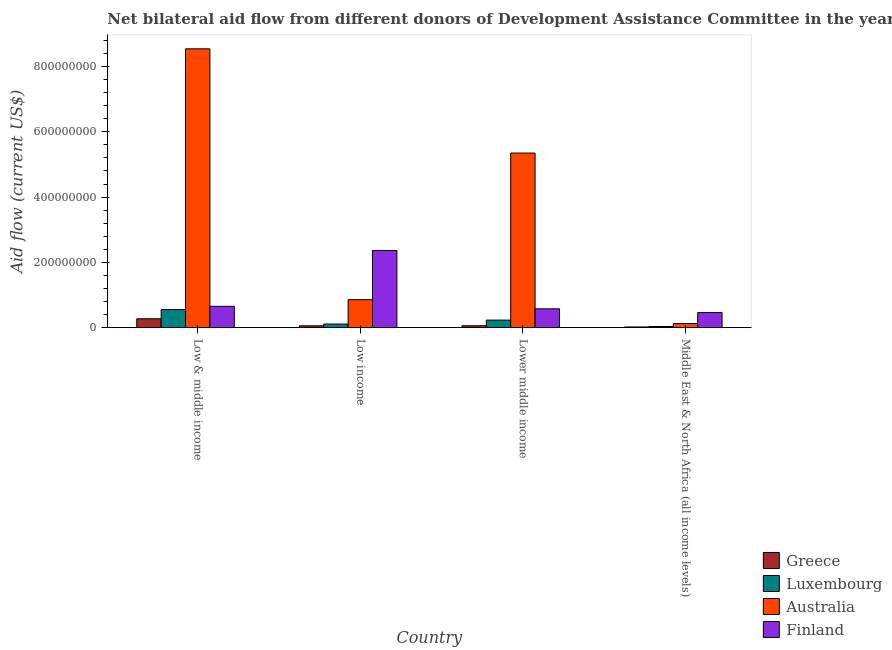How many groups of bars are there?
Offer a terse response. 4. What is the label of the 2nd group of bars from the left?
Your response must be concise. Low income. What is the amount of aid given by luxembourg in Lower middle income?
Give a very brief answer. 2.32e+07. Across all countries, what is the maximum amount of aid given by luxembourg?
Offer a very short reply. 5.56e+07. Across all countries, what is the minimum amount of aid given by finland?
Your answer should be compact. 4.63e+07. In which country was the amount of aid given by greece minimum?
Your response must be concise. Middle East & North Africa (all income levels). What is the total amount of aid given by greece in the graph?
Ensure brevity in your answer.  4.11e+07. What is the difference between the amount of aid given by greece in Low income and that in Lower middle income?
Your answer should be compact. -2.10e+05. What is the difference between the amount of aid given by australia in Low & middle income and the amount of aid given by luxembourg in Middle East & North Africa (all income levels)?
Make the answer very short. 8.51e+08. What is the average amount of aid given by australia per country?
Your answer should be compact. 3.72e+08. What is the difference between the amount of aid given by luxembourg and amount of aid given by australia in Low & middle income?
Offer a very short reply. -7.98e+08. What is the ratio of the amount of aid given by australia in Low income to that in Lower middle income?
Keep it short and to the point. 0.16. Is the difference between the amount of aid given by finland in Low income and Middle East & North Africa (all income levels) greater than the difference between the amount of aid given by greece in Low income and Middle East & North Africa (all income levels)?
Your answer should be very brief. Yes. What is the difference between the highest and the second highest amount of aid given by finland?
Ensure brevity in your answer.  1.71e+08. What is the difference between the highest and the lowest amount of aid given by finland?
Provide a succinct answer. 1.90e+08. Are all the bars in the graph horizontal?
Your answer should be very brief. No. Does the graph contain grids?
Your response must be concise. No. Where does the legend appear in the graph?
Provide a succinct answer. Bottom right. How are the legend labels stacked?
Give a very brief answer. Vertical. What is the title of the graph?
Your answer should be compact. Net bilateral aid flow from different donors of Development Assistance Committee in the year 1996. Does "Efficiency of custom clearance process" appear as one of the legend labels in the graph?
Provide a short and direct response. No. What is the Aid flow (current US$) in Greece in Low & middle income?
Provide a succinct answer. 2.73e+07. What is the Aid flow (current US$) in Luxembourg in Low & middle income?
Offer a very short reply. 5.56e+07. What is the Aid flow (current US$) of Australia in Low & middle income?
Keep it short and to the point. 8.54e+08. What is the Aid flow (current US$) in Finland in Low & middle income?
Keep it short and to the point. 6.54e+07. What is the Aid flow (current US$) in Greece in Low income?
Your answer should be compact. 5.72e+06. What is the Aid flow (current US$) of Luxembourg in Low income?
Offer a very short reply. 1.12e+07. What is the Aid flow (current US$) of Australia in Low income?
Make the answer very short. 8.58e+07. What is the Aid flow (current US$) in Finland in Low income?
Provide a succinct answer. 2.36e+08. What is the Aid flow (current US$) of Greece in Lower middle income?
Offer a very short reply. 5.93e+06. What is the Aid flow (current US$) of Luxembourg in Lower middle income?
Provide a short and direct response. 2.32e+07. What is the Aid flow (current US$) of Australia in Lower middle income?
Make the answer very short. 5.35e+08. What is the Aid flow (current US$) in Finland in Lower middle income?
Your response must be concise. 5.77e+07. What is the Aid flow (current US$) in Greece in Middle East & North Africa (all income levels)?
Ensure brevity in your answer.  2.15e+06. What is the Aid flow (current US$) in Luxembourg in Middle East & North Africa (all income levels)?
Provide a succinct answer. 3.48e+06. What is the Aid flow (current US$) in Australia in Middle East & North Africa (all income levels)?
Your answer should be very brief. 1.26e+07. What is the Aid flow (current US$) in Finland in Middle East & North Africa (all income levels)?
Provide a short and direct response. 4.63e+07. Across all countries, what is the maximum Aid flow (current US$) in Greece?
Your answer should be compact. 2.73e+07. Across all countries, what is the maximum Aid flow (current US$) of Luxembourg?
Your response must be concise. 5.56e+07. Across all countries, what is the maximum Aid flow (current US$) of Australia?
Provide a short and direct response. 8.54e+08. Across all countries, what is the maximum Aid flow (current US$) in Finland?
Provide a succinct answer. 2.36e+08. Across all countries, what is the minimum Aid flow (current US$) of Greece?
Your answer should be compact. 2.15e+06. Across all countries, what is the minimum Aid flow (current US$) of Luxembourg?
Offer a very short reply. 3.48e+06. Across all countries, what is the minimum Aid flow (current US$) in Australia?
Give a very brief answer. 1.26e+07. Across all countries, what is the minimum Aid flow (current US$) of Finland?
Your response must be concise. 4.63e+07. What is the total Aid flow (current US$) of Greece in the graph?
Offer a very short reply. 4.11e+07. What is the total Aid flow (current US$) of Luxembourg in the graph?
Your answer should be compact. 9.35e+07. What is the total Aid flow (current US$) of Australia in the graph?
Ensure brevity in your answer.  1.49e+09. What is the total Aid flow (current US$) in Finland in the graph?
Offer a terse response. 4.06e+08. What is the difference between the Aid flow (current US$) in Greece in Low & middle income and that in Low income?
Ensure brevity in your answer.  2.16e+07. What is the difference between the Aid flow (current US$) in Luxembourg in Low & middle income and that in Low income?
Provide a short and direct response. 4.45e+07. What is the difference between the Aid flow (current US$) of Australia in Low & middle income and that in Low income?
Provide a short and direct response. 7.68e+08. What is the difference between the Aid flow (current US$) in Finland in Low & middle income and that in Low income?
Your answer should be very brief. -1.71e+08. What is the difference between the Aid flow (current US$) of Greece in Low & middle income and that in Lower middle income?
Provide a succinct answer. 2.14e+07. What is the difference between the Aid flow (current US$) of Luxembourg in Low & middle income and that in Lower middle income?
Your response must be concise. 3.24e+07. What is the difference between the Aid flow (current US$) of Australia in Low & middle income and that in Lower middle income?
Provide a succinct answer. 3.19e+08. What is the difference between the Aid flow (current US$) of Finland in Low & middle income and that in Lower middle income?
Your answer should be compact. 7.66e+06. What is the difference between the Aid flow (current US$) of Greece in Low & middle income and that in Middle East & North Africa (all income levels)?
Give a very brief answer. 2.52e+07. What is the difference between the Aid flow (current US$) in Luxembourg in Low & middle income and that in Middle East & North Africa (all income levels)?
Provide a short and direct response. 5.22e+07. What is the difference between the Aid flow (current US$) in Australia in Low & middle income and that in Middle East & North Africa (all income levels)?
Ensure brevity in your answer.  8.41e+08. What is the difference between the Aid flow (current US$) of Finland in Low & middle income and that in Middle East & North Africa (all income levels)?
Your answer should be compact. 1.91e+07. What is the difference between the Aid flow (current US$) in Luxembourg in Low income and that in Lower middle income?
Provide a succinct answer. -1.20e+07. What is the difference between the Aid flow (current US$) of Australia in Low income and that in Lower middle income?
Ensure brevity in your answer.  -4.49e+08. What is the difference between the Aid flow (current US$) of Finland in Low income and that in Lower middle income?
Your answer should be compact. 1.79e+08. What is the difference between the Aid flow (current US$) of Greece in Low income and that in Middle East & North Africa (all income levels)?
Provide a short and direct response. 3.57e+06. What is the difference between the Aid flow (current US$) of Luxembourg in Low income and that in Middle East & North Africa (all income levels)?
Provide a short and direct response. 7.69e+06. What is the difference between the Aid flow (current US$) in Australia in Low income and that in Middle East & North Africa (all income levels)?
Ensure brevity in your answer.  7.32e+07. What is the difference between the Aid flow (current US$) of Finland in Low income and that in Middle East & North Africa (all income levels)?
Ensure brevity in your answer.  1.90e+08. What is the difference between the Aid flow (current US$) in Greece in Lower middle income and that in Middle East & North Africa (all income levels)?
Offer a terse response. 3.78e+06. What is the difference between the Aid flow (current US$) in Luxembourg in Lower middle income and that in Middle East & North Africa (all income levels)?
Make the answer very short. 1.97e+07. What is the difference between the Aid flow (current US$) of Australia in Lower middle income and that in Middle East & North Africa (all income levels)?
Your answer should be very brief. 5.22e+08. What is the difference between the Aid flow (current US$) in Finland in Lower middle income and that in Middle East & North Africa (all income levels)?
Make the answer very short. 1.14e+07. What is the difference between the Aid flow (current US$) of Greece in Low & middle income and the Aid flow (current US$) of Luxembourg in Low income?
Provide a short and direct response. 1.61e+07. What is the difference between the Aid flow (current US$) in Greece in Low & middle income and the Aid flow (current US$) in Australia in Low income?
Offer a very short reply. -5.85e+07. What is the difference between the Aid flow (current US$) in Greece in Low & middle income and the Aid flow (current US$) in Finland in Low income?
Give a very brief answer. -2.09e+08. What is the difference between the Aid flow (current US$) in Luxembourg in Low & middle income and the Aid flow (current US$) in Australia in Low income?
Ensure brevity in your answer.  -3.02e+07. What is the difference between the Aid flow (current US$) in Luxembourg in Low & middle income and the Aid flow (current US$) in Finland in Low income?
Provide a succinct answer. -1.81e+08. What is the difference between the Aid flow (current US$) in Australia in Low & middle income and the Aid flow (current US$) in Finland in Low income?
Ensure brevity in your answer.  6.18e+08. What is the difference between the Aid flow (current US$) in Greece in Low & middle income and the Aid flow (current US$) in Luxembourg in Lower middle income?
Make the answer very short. 4.13e+06. What is the difference between the Aid flow (current US$) of Greece in Low & middle income and the Aid flow (current US$) of Australia in Lower middle income?
Your answer should be compact. -5.08e+08. What is the difference between the Aid flow (current US$) of Greece in Low & middle income and the Aid flow (current US$) of Finland in Lower middle income?
Your answer should be compact. -3.04e+07. What is the difference between the Aid flow (current US$) in Luxembourg in Low & middle income and the Aid flow (current US$) in Australia in Lower middle income?
Offer a very short reply. -4.79e+08. What is the difference between the Aid flow (current US$) in Luxembourg in Low & middle income and the Aid flow (current US$) in Finland in Lower middle income?
Offer a terse response. -2.08e+06. What is the difference between the Aid flow (current US$) of Australia in Low & middle income and the Aid flow (current US$) of Finland in Lower middle income?
Provide a short and direct response. 7.96e+08. What is the difference between the Aid flow (current US$) in Greece in Low & middle income and the Aid flow (current US$) in Luxembourg in Middle East & North Africa (all income levels)?
Provide a succinct answer. 2.38e+07. What is the difference between the Aid flow (current US$) of Greece in Low & middle income and the Aid flow (current US$) of Australia in Middle East & North Africa (all income levels)?
Keep it short and to the point. 1.47e+07. What is the difference between the Aid flow (current US$) of Greece in Low & middle income and the Aid flow (current US$) of Finland in Middle East & North Africa (all income levels)?
Your answer should be compact. -1.90e+07. What is the difference between the Aid flow (current US$) of Luxembourg in Low & middle income and the Aid flow (current US$) of Australia in Middle East & North Africa (all income levels)?
Offer a very short reply. 4.30e+07. What is the difference between the Aid flow (current US$) in Luxembourg in Low & middle income and the Aid flow (current US$) in Finland in Middle East & North Africa (all income levels)?
Keep it short and to the point. 9.36e+06. What is the difference between the Aid flow (current US$) in Australia in Low & middle income and the Aid flow (current US$) in Finland in Middle East & North Africa (all income levels)?
Your response must be concise. 8.08e+08. What is the difference between the Aid flow (current US$) in Greece in Low income and the Aid flow (current US$) in Luxembourg in Lower middle income?
Make the answer very short. -1.75e+07. What is the difference between the Aid flow (current US$) in Greece in Low income and the Aid flow (current US$) in Australia in Lower middle income?
Keep it short and to the point. -5.29e+08. What is the difference between the Aid flow (current US$) in Greece in Low income and the Aid flow (current US$) in Finland in Lower middle income?
Provide a short and direct response. -5.20e+07. What is the difference between the Aid flow (current US$) of Luxembourg in Low income and the Aid flow (current US$) of Australia in Lower middle income?
Your answer should be compact. -5.24e+08. What is the difference between the Aid flow (current US$) of Luxembourg in Low income and the Aid flow (current US$) of Finland in Lower middle income?
Keep it short and to the point. -4.65e+07. What is the difference between the Aid flow (current US$) in Australia in Low income and the Aid flow (current US$) in Finland in Lower middle income?
Your response must be concise. 2.81e+07. What is the difference between the Aid flow (current US$) in Greece in Low income and the Aid flow (current US$) in Luxembourg in Middle East & North Africa (all income levels)?
Offer a terse response. 2.24e+06. What is the difference between the Aid flow (current US$) of Greece in Low income and the Aid flow (current US$) of Australia in Middle East & North Africa (all income levels)?
Your answer should be compact. -6.92e+06. What is the difference between the Aid flow (current US$) in Greece in Low income and the Aid flow (current US$) in Finland in Middle East & North Africa (all income levels)?
Ensure brevity in your answer.  -4.06e+07. What is the difference between the Aid flow (current US$) in Luxembourg in Low income and the Aid flow (current US$) in Australia in Middle East & North Africa (all income levels)?
Your response must be concise. -1.47e+06. What is the difference between the Aid flow (current US$) in Luxembourg in Low income and the Aid flow (current US$) in Finland in Middle East & North Africa (all income levels)?
Make the answer very short. -3.51e+07. What is the difference between the Aid flow (current US$) of Australia in Low income and the Aid flow (current US$) of Finland in Middle East & North Africa (all income levels)?
Provide a short and direct response. 3.96e+07. What is the difference between the Aid flow (current US$) in Greece in Lower middle income and the Aid flow (current US$) in Luxembourg in Middle East & North Africa (all income levels)?
Provide a short and direct response. 2.45e+06. What is the difference between the Aid flow (current US$) in Greece in Lower middle income and the Aid flow (current US$) in Australia in Middle East & North Africa (all income levels)?
Your answer should be very brief. -6.71e+06. What is the difference between the Aid flow (current US$) of Greece in Lower middle income and the Aid flow (current US$) of Finland in Middle East & North Africa (all income levels)?
Give a very brief answer. -4.03e+07. What is the difference between the Aid flow (current US$) of Luxembourg in Lower middle income and the Aid flow (current US$) of Australia in Middle East & North Africa (all income levels)?
Offer a very short reply. 1.05e+07. What is the difference between the Aid flow (current US$) of Luxembourg in Lower middle income and the Aid flow (current US$) of Finland in Middle East & North Africa (all income levels)?
Ensure brevity in your answer.  -2.31e+07. What is the difference between the Aid flow (current US$) in Australia in Lower middle income and the Aid flow (current US$) in Finland in Middle East & North Africa (all income levels)?
Offer a very short reply. 4.89e+08. What is the average Aid flow (current US$) of Greece per country?
Give a very brief answer. 1.03e+07. What is the average Aid flow (current US$) of Luxembourg per country?
Provide a short and direct response. 2.34e+07. What is the average Aid flow (current US$) of Australia per country?
Keep it short and to the point. 3.72e+08. What is the average Aid flow (current US$) in Finland per country?
Offer a terse response. 1.01e+08. What is the difference between the Aid flow (current US$) of Greece and Aid flow (current US$) of Luxembourg in Low & middle income?
Provide a short and direct response. -2.83e+07. What is the difference between the Aid flow (current US$) in Greece and Aid flow (current US$) in Australia in Low & middle income?
Your answer should be very brief. -8.27e+08. What is the difference between the Aid flow (current US$) in Greece and Aid flow (current US$) in Finland in Low & middle income?
Your response must be concise. -3.81e+07. What is the difference between the Aid flow (current US$) of Luxembourg and Aid flow (current US$) of Australia in Low & middle income?
Your response must be concise. -7.98e+08. What is the difference between the Aid flow (current US$) in Luxembourg and Aid flow (current US$) in Finland in Low & middle income?
Offer a very short reply. -9.74e+06. What is the difference between the Aid flow (current US$) in Australia and Aid flow (current US$) in Finland in Low & middle income?
Ensure brevity in your answer.  7.89e+08. What is the difference between the Aid flow (current US$) in Greece and Aid flow (current US$) in Luxembourg in Low income?
Offer a terse response. -5.45e+06. What is the difference between the Aid flow (current US$) of Greece and Aid flow (current US$) of Australia in Low income?
Provide a succinct answer. -8.01e+07. What is the difference between the Aid flow (current US$) of Greece and Aid flow (current US$) of Finland in Low income?
Your response must be concise. -2.31e+08. What is the difference between the Aid flow (current US$) of Luxembourg and Aid flow (current US$) of Australia in Low income?
Provide a succinct answer. -7.47e+07. What is the difference between the Aid flow (current US$) in Luxembourg and Aid flow (current US$) in Finland in Low income?
Your answer should be compact. -2.25e+08. What is the difference between the Aid flow (current US$) of Australia and Aid flow (current US$) of Finland in Low income?
Ensure brevity in your answer.  -1.51e+08. What is the difference between the Aid flow (current US$) in Greece and Aid flow (current US$) in Luxembourg in Lower middle income?
Your answer should be compact. -1.72e+07. What is the difference between the Aid flow (current US$) in Greece and Aid flow (current US$) in Australia in Lower middle income?
Your answer should be very brief. -5.29e+08. What is the difference between the Aid flow (current US$) in Greece and Aid flow (current US$) in Finland in Lower middle income?
Give a very brief answer. -5.18e+07. What is the difference between the Aid flow (current US$) of Luxembourg and Aid flow (current US$) of Australia in Lower middle income?
Provide a succinct answer. -5.12e+08. What is the difference between the Aid flow (current US$) of Luxembourg and Aid flow (current US$) of Finland in Lower middle income?
Ensure brevity in your answer.  -3.45e+07. What is the difference between the Aid flow (current US$) of Australia and Aid flow (current US$) of Finland in Lower middle income?
Offer a very short reply. 4.77e+08. What is the difference between the Aid flow (current US$) in Greece and Aid flow (current US$) in Luxembourg in Middle East & North Africa (all income levels)?
Make the answer very short. -1.33e+06. What is the difference between the Aid flow (current US$) in Greece and Aid flow (current US$) in Australia in Middle East & North Africa (all income levels)?
Provide a short and direct response. -1.05e+07. What is the difference between the Aid flow (current US$) of Greece and Aid flow (current US$) of Finland in Middle East & North Africa (all income levels)?
Give a very brief answer. -4.41e+07. What is the difference between the Aid flow (current US$) of Luxembourg and Aid flow (current US$) of Australia in Middle East & North Africa (all income levels)?
Your answer should be compact. -9.16e+06. What is the difference between the Aid flow (current US$) of Luxembourg and Aid flow (current US$) of Finland in Middle East & North Africa (all income levels)?
Provide a succinct answer. -4.28e+07. What is the difference between the Aid flow (current US$) of Australia and Aid flow (current US$) of Finland in Middle East & North Africa (all income levels)?
Your answer should be compact. -3.36e+07. What is the ratio of the Aid flow (current US$) of Greece in Low & middle income to that in Low income?
Give a very brief answer. 4.77. What is the ratio of the Aid flow (current US$) in Luxembourg in Low & middle income to that in Low income?
Keep it short and to the point. 4.98. What is the ratio of the Aid flow (current US$) in Australia in Low & middle income to that in Low income?
Your answer should be very brief. 9.95. What is the ratio of the Aid flow (current US$) in Finland in Low & middle income to that in Low income?
Your response must be concise. 0.28. What is the ratio of the Aid flow (current US$) in Greece in Low & middle income to that in Lower middle income?
Make the answer very short. 4.61. What is the ratio of the Aid flow (current US$) of Luxembourg in Low & middle income to that in Lower middle income?
Ensure brevity in your answer.  2.4. What is the ratio of the Aid flow (current US$) in Australia in Low & middle income to that in Lower middle income?
Make the answer very short. 1.6. What is the ratio of the Aid flow (current US$) of Finland in Low & middle income to that in Lower middle income?
Make the answer very short. 1.13. What is the ratio of the Aid flow (current US$) of Greece in Low & middle income to that in Middle East & North Africa (all income levels)?
Keep it short and to the point. 12.7. What is the ratio of the Aid flow (current US$) in Luxembourg in Low & middle income to that in Middle East & North Africa (all income levels)?
Your response must be concise. 15.99. What is the ratio of the Aid flow (current US$) of Australia in Low & middle income to that in Middle East & North Africa (all income levels)?
Provide a short and direct response. 67.57. What is the ratio of the Aid flow (current US$) in Finland in Low & middle income to that in Middle East & North Africa (all income levels)?
Your response must be concise. 1.41. What is the ratio of the Aid flow (current US$) in Greece in Low income to that in Lower middle income?
Your answer should be compact. 0.96. What is the ratio of the Aid flow (current US$) in Luxembourg in Low income to that in Lower middle income?
Ensure brevity in your answer.  0.48. What is the ratio of the Aid flow (current US$) in Australia in Low income to that in Lower middle income?
Your answer should be very brief. 0.16. What is the ratio of the Aid flow (current US$) of Finland in Low income to that in Lower middle income?
Your answer should be compact. 4.1. What is the ratio of the Aid flow (current US$) in Greece in Low income to that in Middle East & North Africa (all income levels)?
Offer a very short reply. 2.66. What is the ratio of the Aid flow (current US$) in Luxembourg in Low income to that in Middle East & North Africa (all income levels)?
Offer a terse response. 3.21. What is the ratio of the Aid flow (current US$) in Australia in Low income to that in Middle East & North Africa (all income levels)?
Keep it short and to the point. 6.79. What is the ratio of the Aid flow (current US$) of Finland in Low income to that in Middle East & North Africa (all income levels)?
Offer a terse response. 5.11. What is the ratio of the Aid flow (current US$) of Greece in Lower middle income to that in Middle East & North Africa (all income levels)?
Your response must be concise. 2.76. What is the ratio of the Aid flow (current US$) in Luxembourg in Lower middle income to that in Middle East & North Africa (all income levels)?
Ensure brevity in your answer.  6.66. What is the ratio of the Aid flow (current US$) in Australia in Lower middle income to that in Middle East & North Africa (all income levels)?
Your answer should be compact. 42.31. What is the ratio of the Aid flow (current US$) in Finland in Lower middle income to that in Middle East & North Africa (all income levels)?
Make the answer very short. 1.25. What is the difference between the highest and the second highest Aid flow (current US$) in Greece?
Offer a terse response. 2.14e+07. What is the difference between the highest and the second highest Aid flow (current US$) of Luxembourg?
Your response must be concise. 3.24e+07. What is the difference between the highest and the second highest Aid flow (current US$) in Australia?
Give a very brief answer. 3.19e+08. What is the difference between the highest and the second highest Aid flow (current US$) in Finland?
Provide a short and direct response. 1.71e+08. What is the difference between the highest and the lowest Aid flow (current US$) in Greece?
Ensure brevity in your answer.  2.52e+07. What is the difference between the highest and the lowest Aid flow (current US$) of Luxembourg?
Provide a short and direct response. 5.22e+07. What is the difference between the highest and the lowest Aid flow (current US$) in Australia?
Offer a terse response. 8.41e+08. What is the difference between the highest and the lowest Aid flow (current US$) in Finland?
Provide a short and direct response. 1.90e+08. 